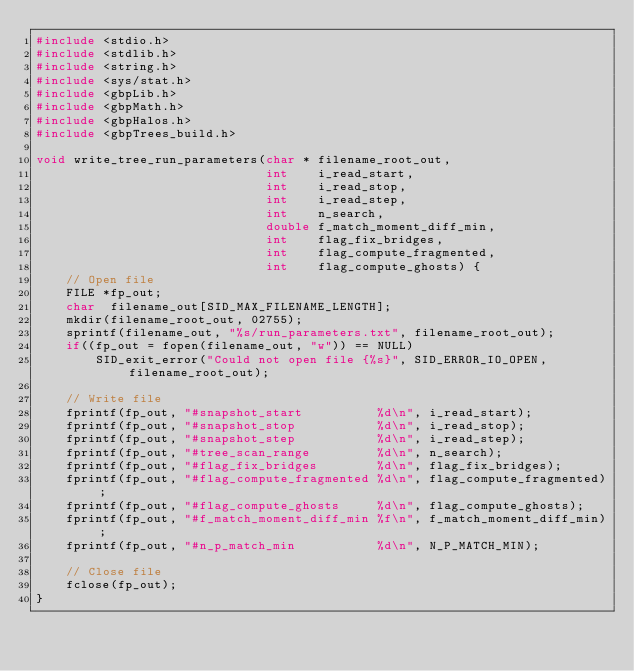Convert code to text. <code><loc_0><loc_0><loc_500><loc_500><_C_>#include <stdio.h>
#include <stdlib.h>
#include <string.h>
#include <sys/stat.h>
#include <gbpLib.h>
#include <gbpMath.h>
#include <gbpHalos.h>
#include <gbpTrees_build.h>

void write_tree_run_parameters(char * filename_root_out,
                               int    i_read_start,
                               int    i_read_stop,
                               int    i_read_step,
                               int    n_search,
                               double f_match_moment_diff_min,
                               int    flag_fix_bridges,
                               int    flag_compute_fragmented,
                               int    flag_compute_ghosts) {
    // Open file
    FILE *fp_out;
    char  filename_out[SID_MAX_FILENAME_LENGTH];
    mkdir(filename_root_out, 02755);
    sprintf(filename_out, "%s/run_parameters.txt", filename_root_out);
    if((fp_out = fopen(filename_out, "w")) == NULL)
        SID_exit_error("Could not open file {%s}", SID_ERROR_IO_OPEN, filename_root_out);

    // Write file
    fprintf(fp_out, "#snapshot_start          %d\n", i_read_start);
    fprintf(fp_out, "#snapshot_stop           %d\n", i_read_stop);
    fprintf(fp_out, "#snapshot_step           %d\n", i_read_step);
    fprintf(fp_out, "#tree_scan_range         %d\n", n_search);
    fprintf(fp_out, "#flag_fix_bridges        %d\n", flag_fix_bridges);
    fprintf(fp_out, "#flag_compute_fragmented %d\n", flag_compute_fragmented);
    fprintf(fp_out, "#flag_compute_ghosts     %d\n", flag_compute_ghosts);
    fprintf(fp_out, "#f_match_moment_diff_min %f\n", f_match_moment_diff_min);
    fprintf(fp_out, "#n_p_match_min           %d\n", N_P_MATCH_MIN);

    // Close file
    fclose(fp_out);
}
</code> 